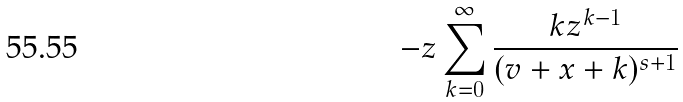<formula> <loc_0><loc_0><loc_500><loc_500>- z \sum _ { k = 0 } ^ { \infty } \frac { k z ^ { k - 1 } } { ( v + x + k ) ^ { s + 1 } }</formula> 